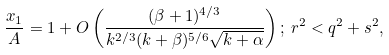<formula> <loc_0><loc_0><loc_500><loc_500>\frac { x _ { 1 } } { A } = 1 + O \left ( \frac { ( \beta + 1 ) ^ { 4 / 3 } } { k ^ { 2 / 3 } ( k + \beta ) ^ { 5 / 6 } \sqrt { k + \alpha } } \right ) ; \, r ^ { 2 } < q ^ { 2 } + s ^ { 2 } ,</formula> 